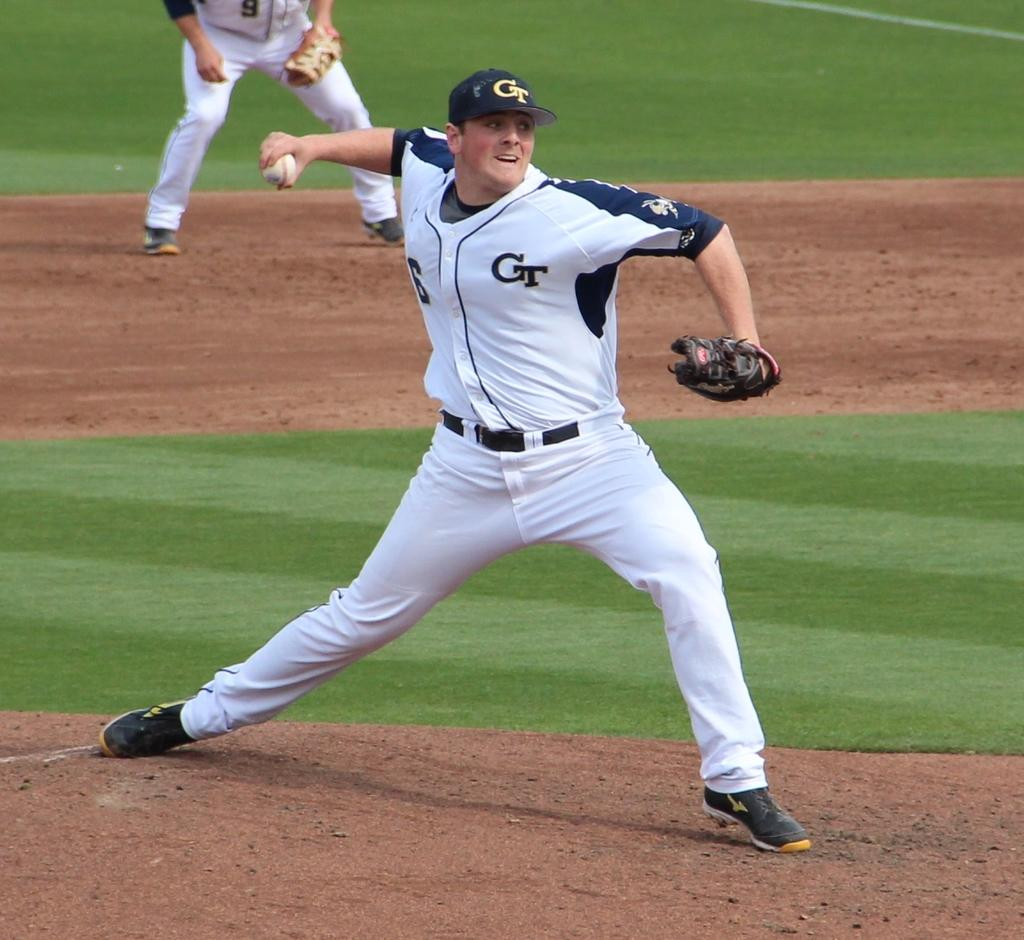<image>
Render a clear and concise summary of the photo. A baseball pitcher is wearing a white CT uniform and a blue CT hat. 